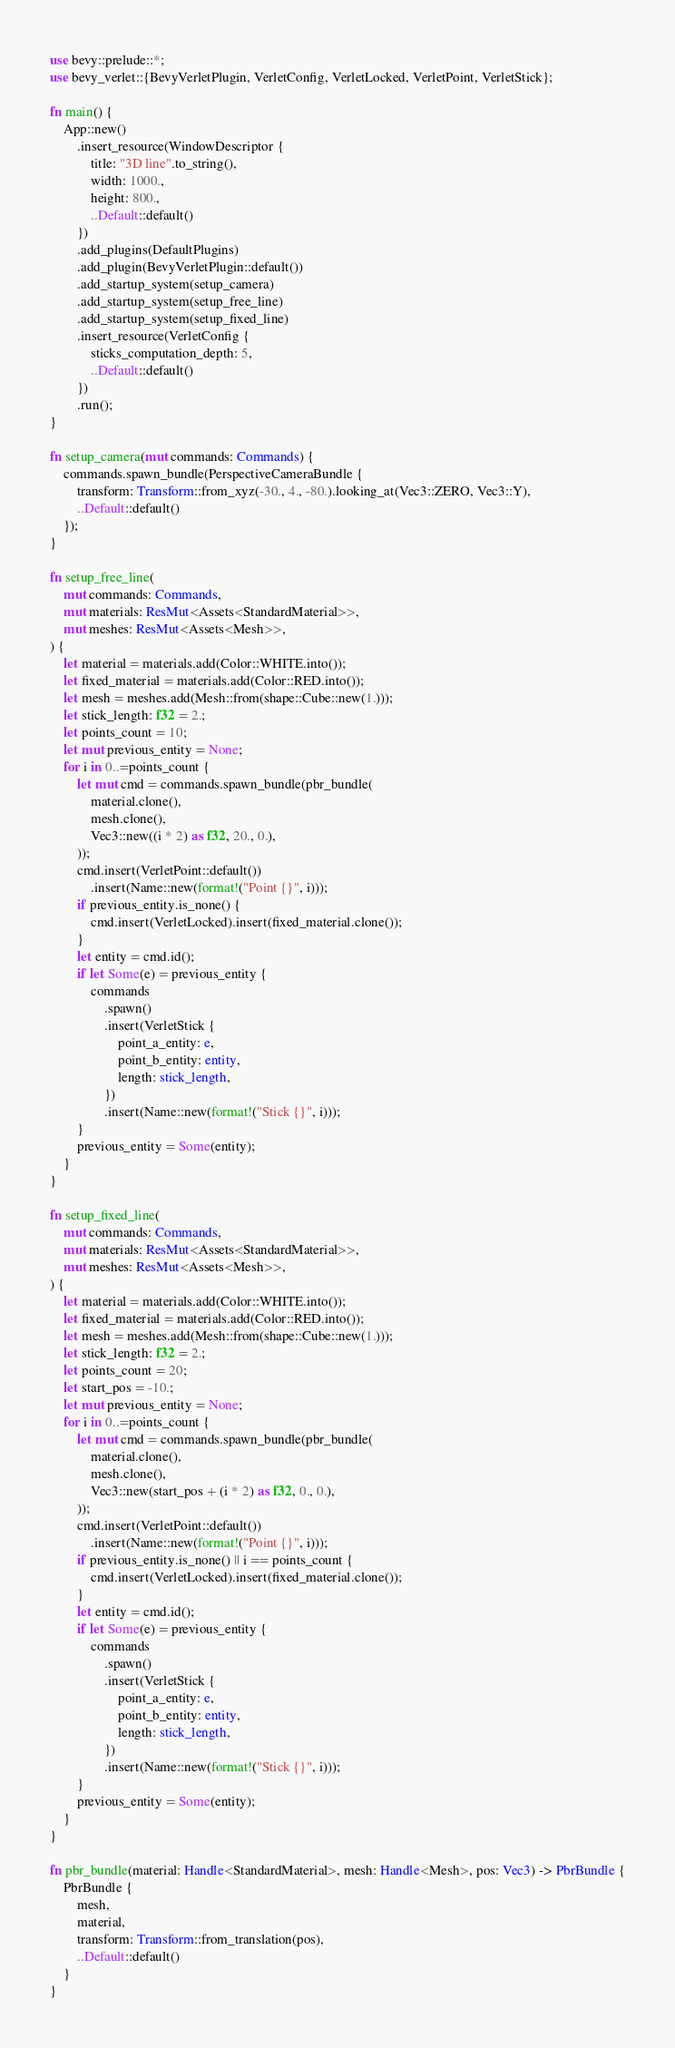Convert code to text. <code><loc_0><loc_0><loc_500><loc_500><_Rust_>use bevy::prelude::*;
use bevy_verlet::{BevyVerletPlugin, VerletConfig, VerletLocked, VerletPoint, VerletStick};

fn main() {
    App::new()
        .insert_resource(WindowDescriptor {
            title: "3D line".to_string(),
            width: 1000.,
            height: 800.,
            ..Default::default()
        })
        .add_plugins(DefaultPlugins)
        .add_plugin(BevyVerletPlugin::default())
        .add_startup_system(setup_camera)
        .add_startup_system(setup_free_line)
        .add_startup_system(setup_fixed_line)
        .insert_resource(VerletConfig {
            sticks_computation_depth: 5,
            ..Default::default()
        })
        .run();
}

fn setup_camera(mut commands: Commands) {
    commands.spawn_bundle(PerspectiveCameraBundle {
        transform: Transform::from_xyz(-30., 4., -80.).looking_at(Vec3::ZERO, Vec3::Y),
        ..Default::default()
    });
}

fn setup_free_line(
    mut commands: Commands,
    mut materials: ResMut<Assets<StandardMaterial>>,
    mut meshes: ResMut<Assets<Mesh>>,
) {
    let material = materials.add(Color::WHITE.into());
    let fixed_material = materials.add(Color::RED.into());
    let mesh = meshes.add(Mesh::from(shape::Cube::new(1.)));
    let stick_length: f32 = 2.;
    let points_count = 10;
    let mut previous_entity = None;
    for i in 0..=points_count {
        let mut cmd = commands.spawn_bundle(pbr_bundle(
            material.clone(),
            mesh.clone(),
            Vec3::new((i * 2) as f32, 20., 0.),
        ));
        cmd.insert(VerletPoint::default())
            .insert(Name::new(format!("Point {}", i)));
        if previous_entity.is_none() {
            cmd.insert(VerletLocked).insert(fixed_material.clone());
        }
        let entity = cmd.id();
        if let Some(e) = previous_entity {
            commands
                .spawn()
                .insert(VerletStick {
                    point_a_entity: e,
                    point_b_entity: entity,
                    length: stick_length,
                })
                .insert(Name::new(format!("Stick {}", i)));
        }
        previous_entity = Some(entity);
    }
}

fn setup_fixed_line(
    mut commands: Commands,
    mut materials: ResMut<Assets<StandardMaterial>>,
    mut meshes: ResMut<Assets<Mesh>>,
) {
    let material = materials.add(Color::WHITE.into());
    let fixed_material = materials.add(Color::RED.into());
    let mesh = meshes.add(Mesh::from(shape::Cube::new(1.)));
    let stick_length: f32 = 2.;
    let points_count = 20;
    let start_pos = -10.;
    let mut previous_entity = None;
    for i in 0..=points_count {
        let mut cmd = commands.spawn_bundle(pbr_bundle(
            material.clone(),
            mesh.clone(),
            Vec3::new(start_pos + (i * 2) as f32, 0., 0.),
        ));
        cmd.insert(VerletPoint::default())
            .insert(Name::new(format!("Point {}", i)));
        if previous_entity.is_none() || i == points_count {
            cmd.insert(VerletLocked).insert(fixed_material.clone());
        }
        let entity = cmd.id();
        if let Some(e) = previous_entity {
            commands
                .spawn()
                .insert(VerletStick {
                    point_a_entity: e,
                    point_b_entity: entity,
                    length: stick_length,
                })
                .insert(Name::new(format!("Stick {}", i)));
        }
        previous_entity = Some(entity);
    }
}

fn pbr_bundle(material: Handle<StandardMaterial>, mesh: Handle<Mesh>, pos: Vec3) -> PbrBundle {
    PbrBundle {
        mesh,
        material,
        transform: Transform::from_translation(pos),
        ..Default::default()
    }
}
</code> 